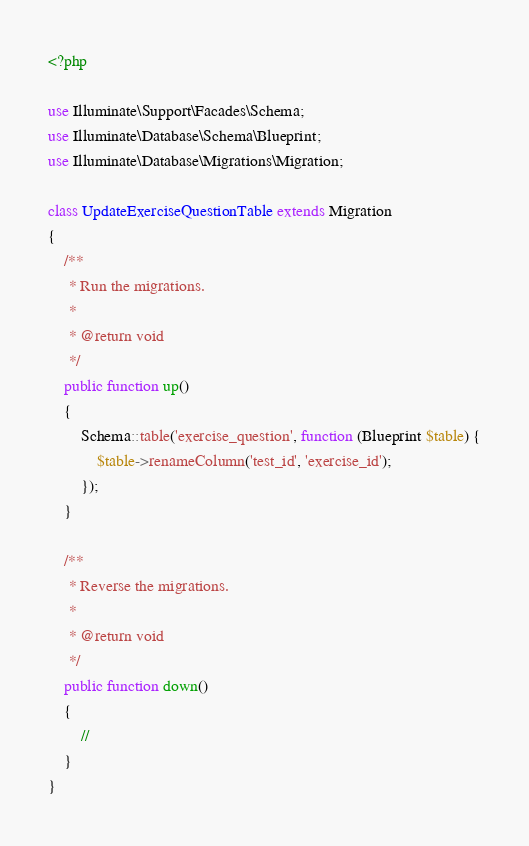<code> <loc_0><loc_0><loc_500><loc_500><_PHP_><?php

use Illuminate\Support\Facades\Schema;
use Illuminate\Database\Schema\Blueprint;
use Illuminate\Database\Migrations\Migration;

class UpdateExerciseQuestionTable extends Migration
{
    /**
     * Run the migrations.
     *
     * @return void
     */
    public function up()
    {
        Schema::table('exercise_question', function (Blueprint $table) {
            $table->renameColumn('test_id', 'exercise_id');
        });
    }

    /**
     * Reverse the migrations.
     *
     * @return void
     */
    public function down()
    {
        //
    }
}
</code> 